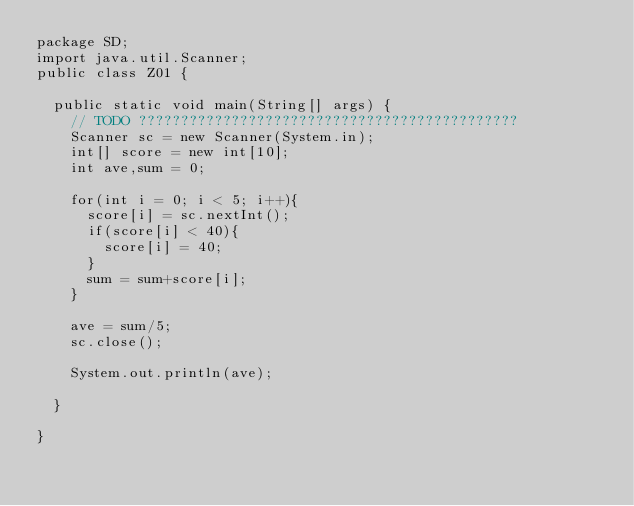Convert code to text. <code><loc_0><loc_0><loc_500><loc_500><_Java_>package SD;
import java.util.Scanner;
public class Z01 {

	public static void main(String[] args) {
		// TODO ?????????????????????????????????????????????
		Scanner sc = new Scanner(System.in);
		int[] score = new int[10];
		int ave,sum = 0;

		for(int i = 0; i < 5; i++){
			score[i] = sc.nextInt();
			if(score[i] < 40){
				score[i] = 40;
			}
			sum = sum+score[i];
		}

		ave = sum/5;
		sc.close();

		System.out.println(ave);

	}

}</code> 